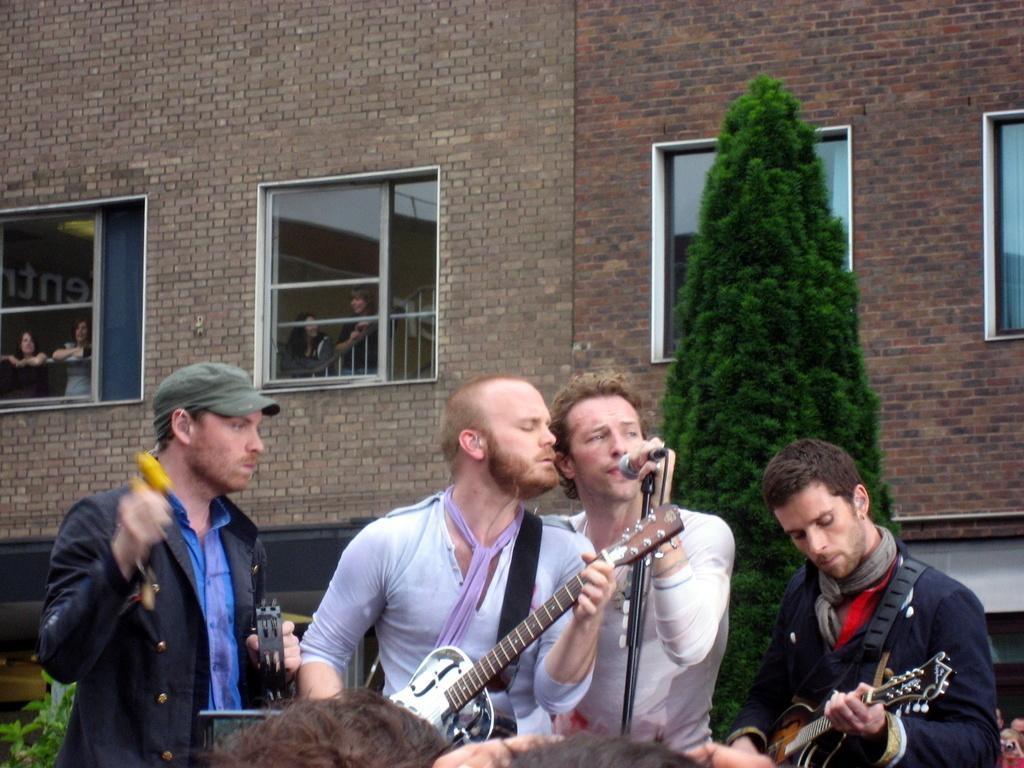What are the people in the image doing? The people in the image are holding musical instruments. What object is present for amplifying sound? There is a microphone in the image. What can be seen in the background of the image? There is a tree and a building with windows in the background of the image. What type of pickle is being served for dinner in the image? There is no dinner or pickle present in the image. 